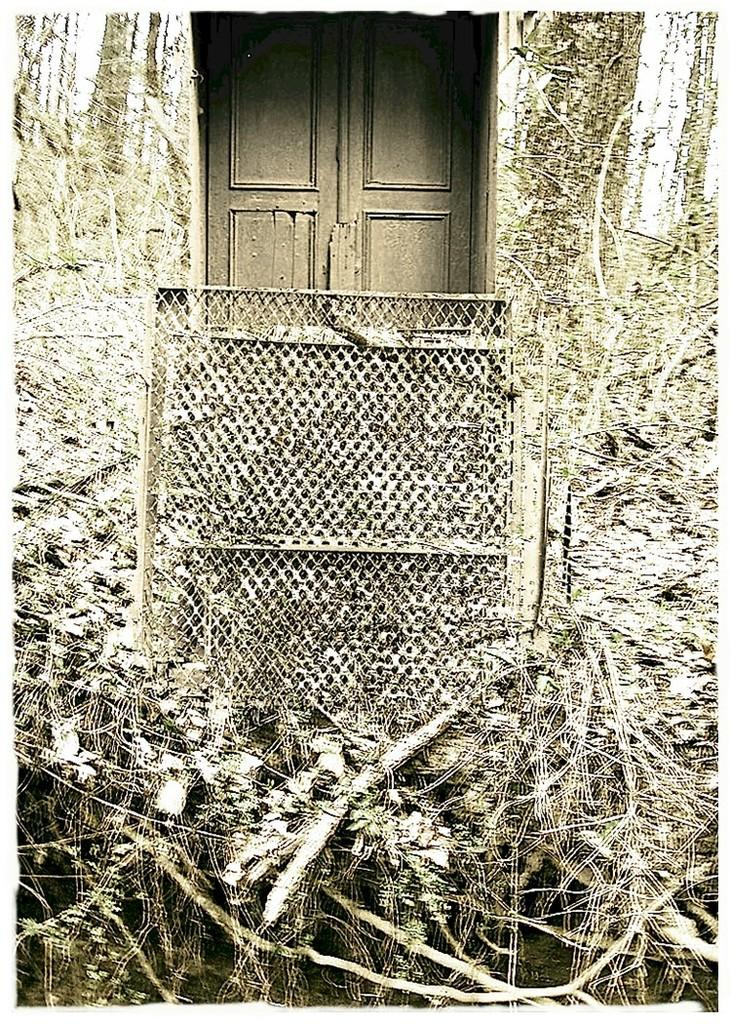What type of living organisms can be seen in the image? Plants can be seen in the image. What type of structure is present in the image? There is fencing in the image. What architectural feature is visible on the wall in the image? There are doors on a wall in the image. What type of birthday celebration is taking place in the image? There is no indication of a birthday celebration in the image. How does the cart move in the image? There is no cart present in the image. 